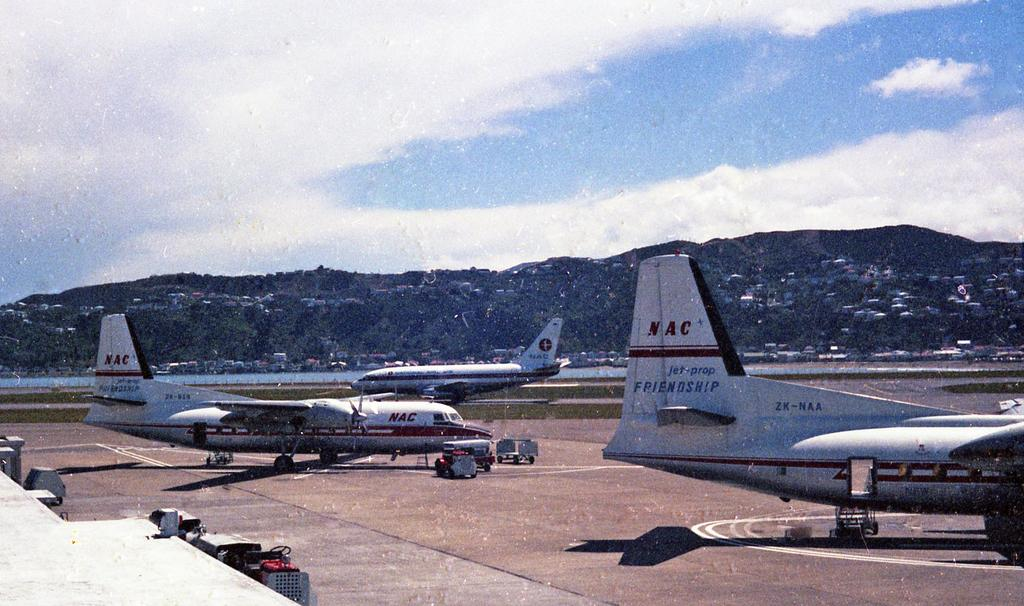What is the main subject of the image? The main subject of the image is aeroplanes. What is located at the bottom of the image? There is a runway at the bottom of the image. What can be seen in the background of the image? There is a hill and the sky visible in the background of the image. What type of bait is being used by the aeroplanes in the image? There is no bait present in the image, as aeroplanes do not use bait. 